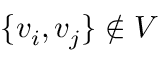Convert formula to latex. <formula><loc_0><loc_0><loc_500><loc_500>\{ v _ { i } , v _ { j } \} \not \in V</formula> 